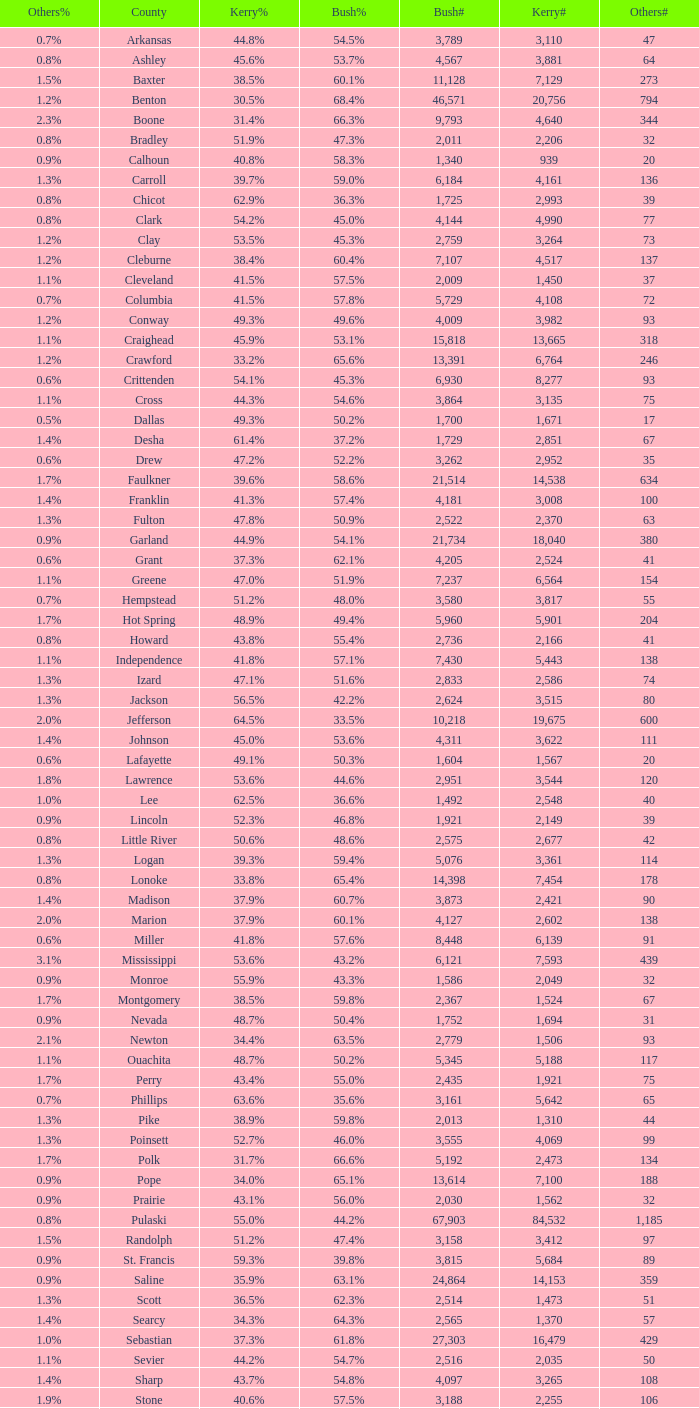What is the lowest Bush#, when Bush% is "65.4%"? 14398.0. 